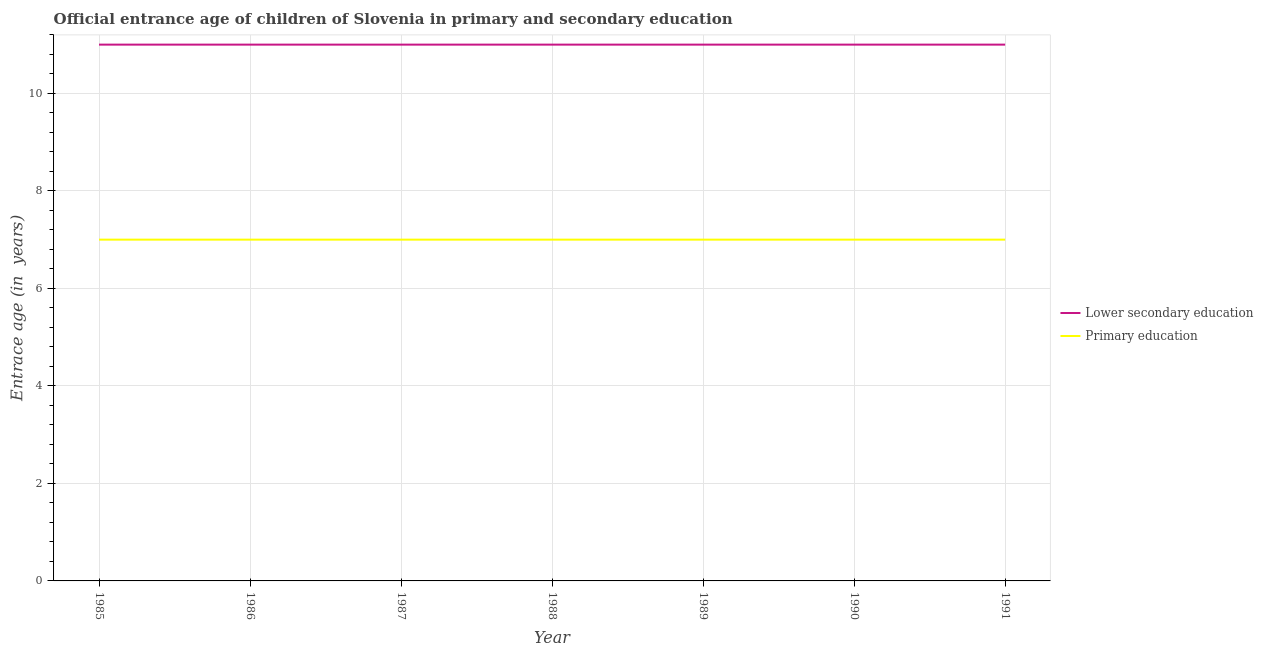Does the line corresponding to entrance age of chiildren in primary education intersect with the line corresponding to entrance age of children in lower secondary education?
Offer a very short reply. No. What is the entrance age of children in lower secondary education in 1988?
Your response must be concise. 11. Across all years, what is the maximum entrance age of children in lower secondary education?
Ensure brevity in your answer.  11. Across all years, what is the minimum entrance age of chiildren in primary education?
Keep it short and to the point. 7. What is the total entrance age of children in lower secondary education in the graph?
Ensure brevity in your answer.  77. What is the difference between the entrance age of chiildren in primary education in 1985 and that in 1991?
Your answer should be compact. 0. What is the difference between the entrance age of children in lower secondary education in 1991 and the entrance age of chiildren in primary education in 1987?
Your answer should be compact. 4. What is the average entrance age of children in lower secondary education per year?
Keep it short and to the point. 11. In the year 1990, what is the difference between the entrance age of children in lower secondary education and entrance age of chiildren in primary education?
Give a very brief answer. 4. Is the entrance age of children in lower secondary education in 1987 less than that in 1991?
Offer a very short reply. No. What is the difference between the highest and the second highest entrance age of children in lower secondary education?
Your answer should be compact. 0. In how many years, is the entrance age of chiildren in primary education greater than the average entrance age of chiildren in primary education taken over all years?
Ensure brevity in your answer.  0. Is the sum of the entrance age of children in lower secondary education in 1989 and 1991 greater than the maximum entrance age of chiildren in primary education across all years?
Your response must be concise. Yes. Is the entrance age of chiildren in primary education strictly greater than the entrance age of children in lower secondary education over the years?
Offer a very short reply. No. Is the entrance age of children in lower secondary education strictly less than the entrance age of chiildren in primary education over the years?
Your response must be concise. No. How many lines are there?
Offer a terse response. 2. What is the difference between two consecutive major ticks on the Y-axis?
Offer a terse response. 2. Where does the legend appear in the graph?
Make the answer very short. Center right. How many legend labels are there?
Offer a terse response. 2. What is the title of the graph?
Your response must be concise. Official entrance age of children of Slovenia in primary and secondary education. Does "External balance on goods" appear as one of the legend labels in the graph?
Ensure brevity in your answer.  No. What is the label or title of the Y-axis?
Provide a short and direct response. Entrace age (in  years). What is the Entrace age (in  years) in Lower secondary education in 1985?
Offer a terse response. 11. What is the Entrace age (in  years) in Primary education in 1985?
Provide a short and direct response. 7. What is the Entrace age (in  years) of Primary education in 1986?
Provide a short and direct response. 7. What is the Entrace age (in  years) of Lower secondary education in 1987?
Provide a short and direct response. 11. What is the Entrace age (in  years) in Primary education in 1987?
Provide a short and direct response. 7. What is the Entrace age (in  years) in Primary education in 1988?
Make the answer very short. 7. What is the Entrace age (in  years) in Primary education in 1989?
Your response must be concise. 7. What is the Entrace age (in  years) of Primary education in 1990?
Offer a terse response. 7. What is the Entrace age (in  years) in Primary education in 1991?
Your response must be concise. 7. Across all years, what is the maximum Entrace age (in  years) in Primary education?
Offer a very short reply. 7. Across all years, what is the minimum Entrace age (in  years) in Lower secondary education?
Provide a short and direct response. 11. Across all years, what is the minimum Entrace age (in  years) in Primary education?
Provide a short and direct response. 7. What is the total Entrace age (in  years) of Primary education in the graph?
Offer a very short reply. 49. What is the difference between the Entrace age (in  years) of Primary education in 1985 and that in 1986?
Keep it short and to the point. 0. What is the difference between the Entrace age (in  years) of Lower secondary education in 1985 and that in 1987?
Offer a terse response. 0. What is the difference between the Entrace age (in  years) of Lower secondary education in 1985 and that in 1988?
Your response must be concise. 0. What is the difference between the Entrace age (in  years) in Primary education in 1985 and that in 1988?
Your answer should be very brief. 0. What is the difference between the Entrace age (in  years) of Lower secondary education in 1985 and that in 1989?
Make the answer very short. 0. What is the difference between the Entrace age (in  years) in Primary education in 1985 and that in 1989?
Offer a very short reply. 0. What is the difference between the Entrace age (in  years) in Lower secondary education in 1985 and that in 1990?
Make the answer very short. 0. What is the difference between the Entrace age (in  years) in Primary education in 1985 and that in 1991?
Offer a terse response. 0. What is the difference between the Entrace age (in  years) of Lower secondary education in 1986 and that in 1989?
Make the answer very short. 0. What is the difference between the Entrace age (in  years) in Primary education in 1986 and that in 1989?
Keep it short and to the point. 0. What is the difference between the Entrace age (in  years) of Lower secondary education in 1986 and that in 1990?
Provide a succinct answer. 0. What is the difference between the Entrace age (in  years) in Primary education in 1986 and that in 1990?
Your answer should be very brief. 0. What is the difference between the Entrace age (in  years) in Lower secondary education in 1987 and that in 1988?
Your response must be concise. 0. What is the difference between the Entrace age (in  years) of Lower secondary education in 1987 and that in 1989?
Provide a succinct answer. 0. What is the difference between the Entrace age (in  years) of Primary education in 1987 and that in 1989?
Provide a short and direct response. 0. What is the difference between the Entrace age (in  years) in Lower secondary education in 1987 and that in 1990?
Provide a succinct answer. 0. What is the difference between the Entrace age (in  years) of Lower secondary education in 1987 and that in 1991?
Your answer should be compact. 0. What is the difference between the Entrace age (in  years) in Primary education in 1987 and that in 1991?
Your answer should be compact. 0. What is the difference between the Entrace age (in  years) of Lower secondary education in 1988 and that in 1991?
Provide a succinct answer. 0. What is the difference between the Entrace age (in  years) of Lower secondary education in 1989 and that in 1991?
Provide a succinct answer. 0. What is the difference between the Entrace age (in  years) of Lower secondary education in 1990 and that in 1991?
Keep it short and to the point. 0. What is the difference between the Entrace age (in  years) of Primary education in 1990 and that in 1991?
Your answer should be very brief. 0. What is the difference between the Entrace age (in  years) of Lower secondary education in 1985 and the Entrace age (in  years) of Primary education in 1987?
Ensure brevity in your answer.  4. What is the difference between the Entrace age (in  years) in Lower secondary education in 1986 and the Entrace age (in  years) in Primary education in 1988?
Offer a terse response. 4. What is the difference between the Entrace age (in  years) of Lower secondary education in 1986 and the Entrace age (in  years) of Primary education in 1989?
Offer a terse response. 4. What is the difference between the Entrace age (in  years) in Lower secondary education in 1987 and the Entrace age (in  years) in Primary education in 1989?
Make the answer very short. 4. What is the difference between the Entrace age (in  years) in Lower secondary education in 1987 and the Entrace age (in  years) in Primary education in 1990?
Your response must be concise. 4. What is the difference between the Entrace age (in  years) of Lower secondary education in 1987 and the Entrace age (in  years) of Primary education in 1991?
Offer a terse response. 4. What is the difference between the Entrace age (in  years) of Lower secondary education in 1988 and the Entrace age (in  years) of Primary education in 1991?
Make the answer very short. 4. What is the difference between the Entrace age (in  years) in Lower secondary education in 1989 and the Entrace age (in  years) in Primary education in 1991?
Offer a very short reply. 4. What is the average Entrace age (in  years) of Primary education per year?
Make the answer very short. 7. In the year 1985, what is the difference between the Entrace age (in  years) of Lower secondary education and Entrace age (in  years) of Primary education?
Your answer should be compact. 4. In the year 1986, what is the difference between the Entrace age (in  years) in Lower secondary education and Entrace age (in  years) in Primary education?
Keep it short and to the point. 4. In the year 1987, what is the difference between the Entrace age (in  years) of Lower secondary education and Entrace age (in  years) of Primary education?
Give a very brief answer. 4. In the year 1989, what is the difference between the Entrace age (in  years) in Lower secondary education and Entrace age (in  years) in Primary education?
Your answer should be compact. 4. In the year 1991, what is the difference between the Entrace age (in  years) of Lower secondary education and Entrace age (in  years) of Primary education?
Provide a short and direct response. 4. What is the ratio of the Entrace age (in  years) of Lower secondary education in 1985 to that in 1986?
Your response must be concise. 1. What is the ratio of the Entrace age (in  years) of Lower secondary education in 1985 to that in 1988?
Make the answer very short. 1. What is the ratio of the Entrace age (in  years) of Primary education in 1985 to that in 1988?
Offer a very short reply. 1. What is the ratio of the Entrace age (in  years) in Lower secondary education in 1985 to that in 1989?
Make the answer very short. 1. What is the ratio of the Entrace age (in  years) of Primary education in 1985 to that in 1989?
Keep it short and to the point. 1. What is the ratio of the Entrace age (in  years) of Primary education in 1985 to that in 1991?
Provide a short and direct response. 1. What is the ratio of the Entrace age (in  years) in Lower secondary education in 1986 to that in 1987?
Your answer should be compact. 1. What is the ratio of the Entrace age (in  years) in Primary education in 1986 to that in 1987?
Ensure brevity in your answer.  1. What is the ratio of the Entrace age (in  years) in Lower secondary education in 1986 to that in 1988?
Make the answer very short. 1. What is the ratio of the Entrace age (in  years) in Primary education in 1986 to that in 1988?
Your response must be concise. 1. What is the ratio of the Entrace age (in  years) in Lower secondary education in 1986 to that in 1989?
Give a very brief answer. 1. What is the ratio of the Entrace age (in  years) of Primary education in 1986 to that in 1989?
Offer a very short reply. 1. What is the ratio of the Entrace age (in  years) in Primary education in 1986 to that in 1991?
Your answer should be very brief. 1. What is the ratio of the Entrace age (in  years) in Primary education in 1987 to that in 1988?
Offer a very short reply. 1. What is the ratio of the Entrace age (in  years) in Lower secondary education in 1987 to that in 1989?
Provide a short and direct response. 1. What is the ratio of the Entrace age (in  years) in Primary education in 1987 to that in 1991?
Give a very brief answer. 1. What is the ratio of the Entrace age (in  years) of Primary education in 1988 to that in 1990?
Provide a succinct answer. 1. What is the ratio of the Entrace age (in  years) of Lower secondary education in 1988 to that in 1991?
Offer a very short reply. 1. What is the ratio of the Entrace age (in  years) in Primary education in 1988 to that in 1991?
Keep it short and to the point. 1. What is the ratio of the Entrace age (in  years) of Primary education in 1989 to that in 1990?
Provide a succinct answer. 1. What is the ratio of the Entrace age (in  years) in Primary education in 1989 to that in 1991?
Give a very brief answer. 1. What is the difference between the highest and the second highest Entrace age (in  years) in Lower secondary education?
Ensure brevity in your answer.  0. What is the difference between the highest and the second highest Entrace age (in  years) in Primary education?
Keep it short and to the point. 0. What is the difference between the highest and the lowest Entrace age (in  years) in Lower secondary education?
Your answer should be very brief. 0. 